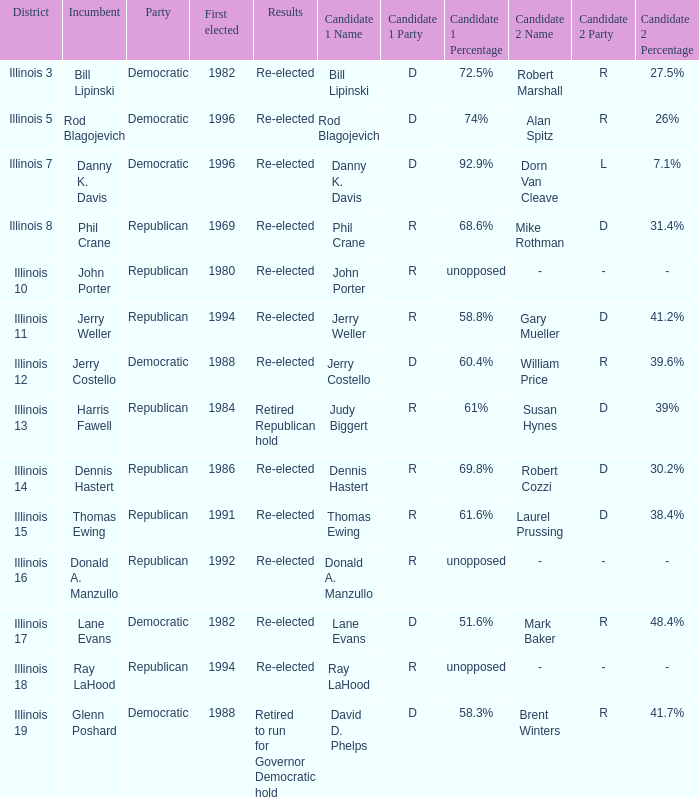Who were the candidates in the district where Jerry Costello won? Jerry Costello (D) 60.4% William Price (R) 39.6%. 